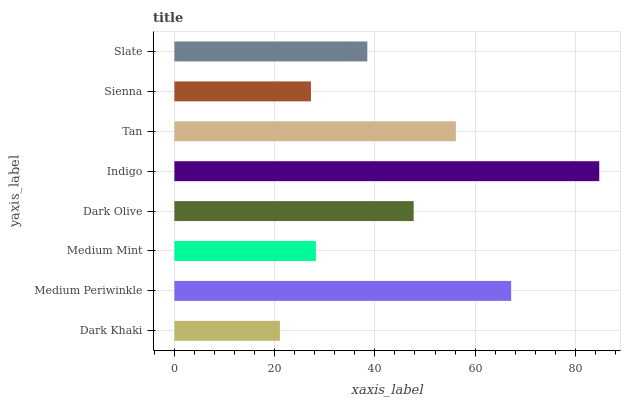Is Dark Khaki the minimum?
Answer yes or no. Yes. Is Indigo the maximum?
Answer yes or no. Yes. Is Medium Periwinkle the minimum?
Answer yes or no. No. Is Medium Periwinkle the maximum?
Answer yes or no. No. Is Medium Periwinkle greater than Dark Khaki?
Answer yes or no. Yes. Is Dark Khaki less than Medium Periwinkle?
Answer yes or no. Yes. Is Dark Khaki greater than Medium Periwinkle?
Answer yes or no. No. Is Medium Periwinkle less than Dark Khaki?
Answer yes or no. No. Is Dark Olive the high median?
Answer yes or no. Yes. Is Slate the low median?
Answer yes or no. Yes. Is Medium Mint the high median?
Answer yes or no. No. Is Medium Mint the low median?
Answer yes or no. No. 